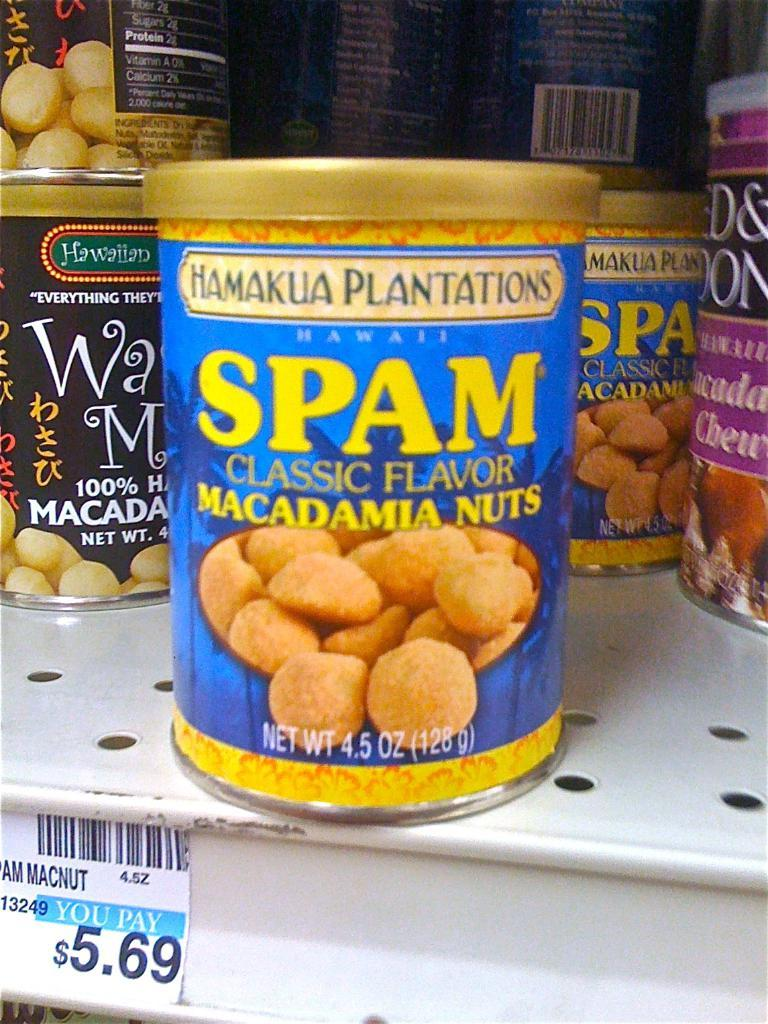What type of items are visible in the image? There are food cans in the image. Where are the food cans placed? The food cans are on an iron object. Is there any information about the price of the items in the image? Yes, there is a price sticker in the image. What type of body of water can be seen in the image? There is no body of water present in the image; it features food cans on an iron object with a price sticker. How many beds are visible in the image? There are no beds present in the image. 